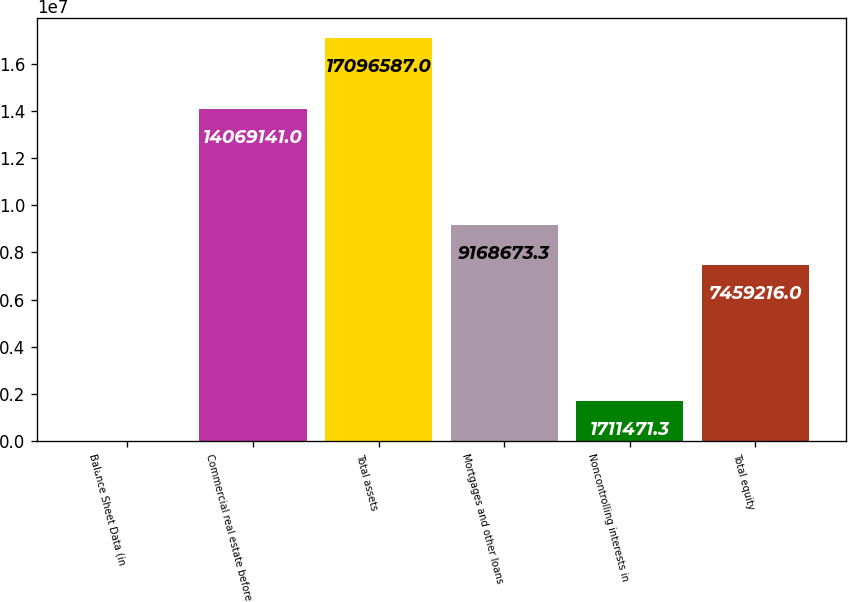<chart> <loc_0><loc_0><loc_500><loc_500><bar_chart><fcel>Balance Sheet Data (in<fcel>Commercial real estate before<fcel>Total assets<fcel>Mortgages and other loans<fcel>Noncontrolling interests in<fcel>Total equity<nl><fcel>2014<fcel>1.40691e+07<fcel>1.70966e+07<fcel>9.16867e+06<fcel>1.71147e+06<fcel>7.45922e+06<nl></chart> 